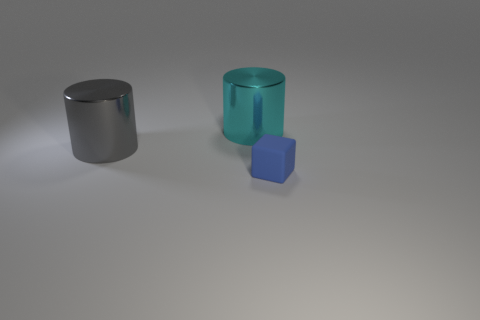Does the small thing have the same shape as the cyan object?
Make the answer very short. No. How many objects are either objects that are behind the small blue block or tiny matte cubes?
Give a very brief answer. 3. There is a blue matte thing to the right of the large cylinder that is in front of the big metal object that is right of the large gray shiny object; what shape is it?
Your answer should be compact. Cube. What is the shape of the other object that is made of the same material as the big gray thing?
Your response must be concise. Cylinder. What size is the block?
Your response must be concise. Small. Does the cube have the same size as the cyan cylinder?
Your response must be concise. No. How many objects are either large metal cylinders that are right of the big gray metallic cylinder or big objects on the left side of the cyan object?
Offer a very short reply. 2. There is a big metallic cylinder in front of the big metal object that is to the right of the gray thing; how many large things are behind it?
Make the answer very short. 1. What is the size of the cylinder that is left of the large cyan thing?
Your answer should be compact. Large. How many cylinders have the same size as the blue cube?
Offer a terse response. 0. 